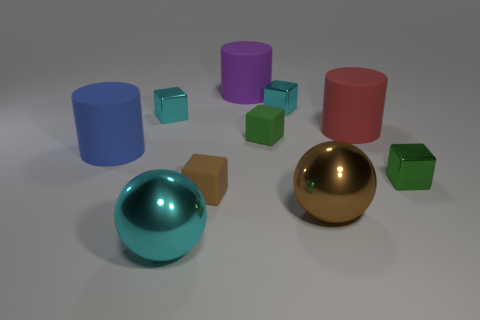Is the number of green objects to the right of the tiny green shiny cube less than the number of matte objects that are to the right of the blue cylinder?
Provide a succinct answer. Yes. What is the size of the shiny cube to the left of the big shiny thing to the left of the small green object left of the red matte thing?
Ensure brevity in your answer.  Small. What is the size of the metal object that is to the left of the tiny green matte cube and in front of the large red rubber cylinder?
Ensure brevity in your answer.  Large. What is the shape of the small green object to the left of the tiny cyan metallic block that is right of the brown block?
Make the answer very short. Cube. What shape is the small matte thing that is in front of the small green rubber cube?
Your answer should be very brief. Cube. What shape is the metallic thing that is both behind the brown shiny object and left of the tiny green rubber block?
Offer a very short reply. Cube. What number of yellow objects are small rubber things or metal things?
Ensure brevity in your answer.  0. What is the size of the cyan object in front of the big rubber cylinder that is on the left side of the big cyan ball?
Ensure brevity in your answer.  Large. There is a cyan ball that is the same size as the brown metallic object; what is it made of?
Make the answer very short. Metal. What number of other things are the same size as the purple rubber cylinder?
Your response must be concise. 4. 